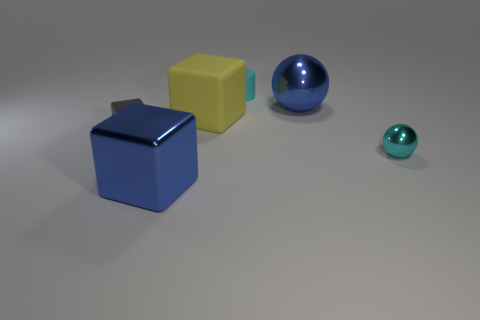Add 2 small red matte cubes. How many objects exist? 8 Subtract all cylinders. How many objects are left? 5 Subtract all small cubes. Subtract all big metallic cubes. How many objects are left? 4 Add 2 cyan metallic spheres. How many cyan metallic spheres are left? 3 Add 3 yellow things. How many yellow things exist? 4 Subtract 0 gray cylinders. How many objects are left? 6 